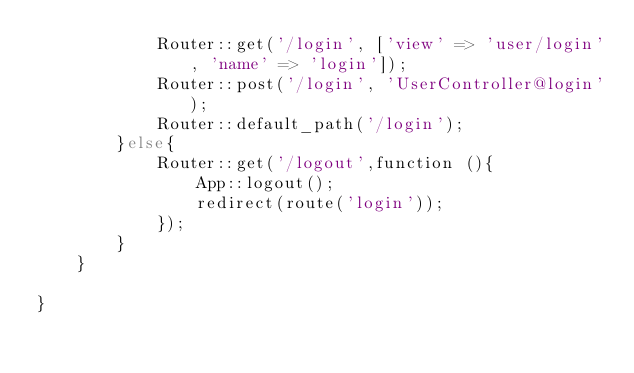<code> <loc_0><loc_0><loc_500><loc_500><_PHP_>            Router::get('/login', ['view' => 'user/login', 'name' => 'login']);
            Router::post('/login', 'UserController@login');
            Router::default_path('/login');
        }else{
            Router::get('/logout',function (){
                App::logout();
                redirect(route('login'));
            });
        }
    }

}</code> 